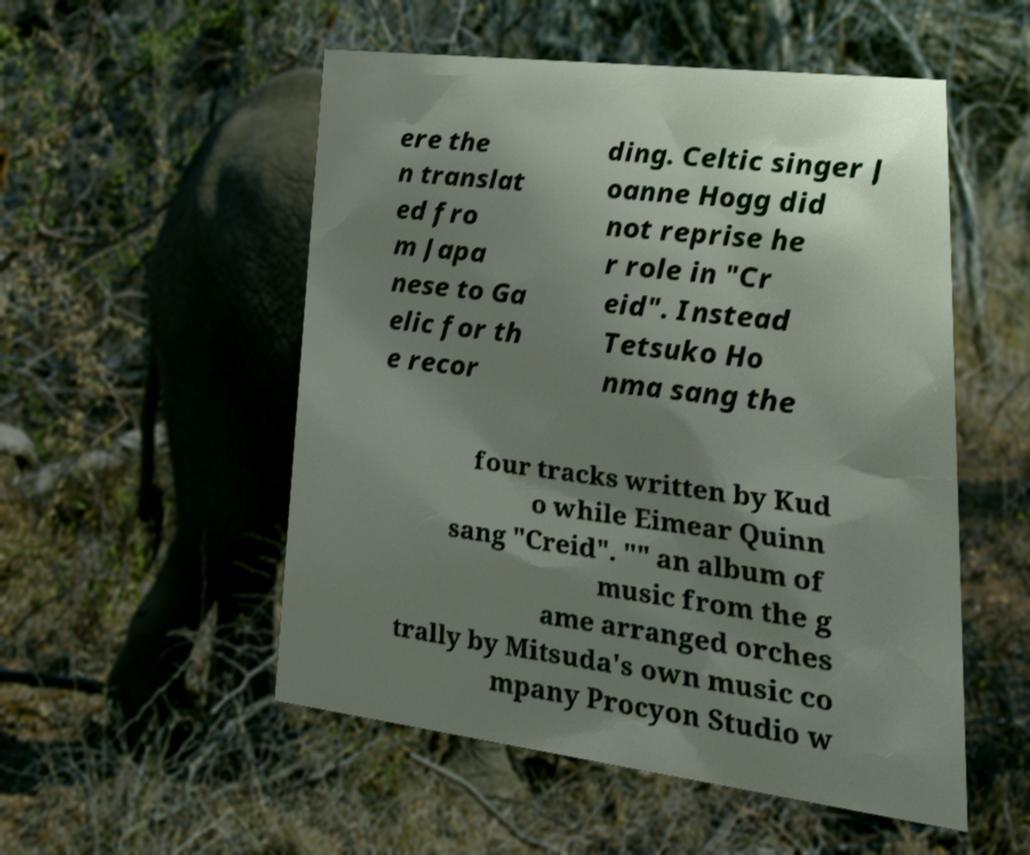Could you extract and type out the text from this image? ere the n translat ed fro m Japa nese to Ga elic for th e recor ding. Celtic singer J oanne Hogg did not reprise he r role in "Cr eid". Instead Tetsuko Ho nma sang the four tracks written by Kud o while Eimear Quinn sang "Creid". "" an album of music from the g ame arranged orches trally by Mitsuda's own music co mpany Procyon Studio w 